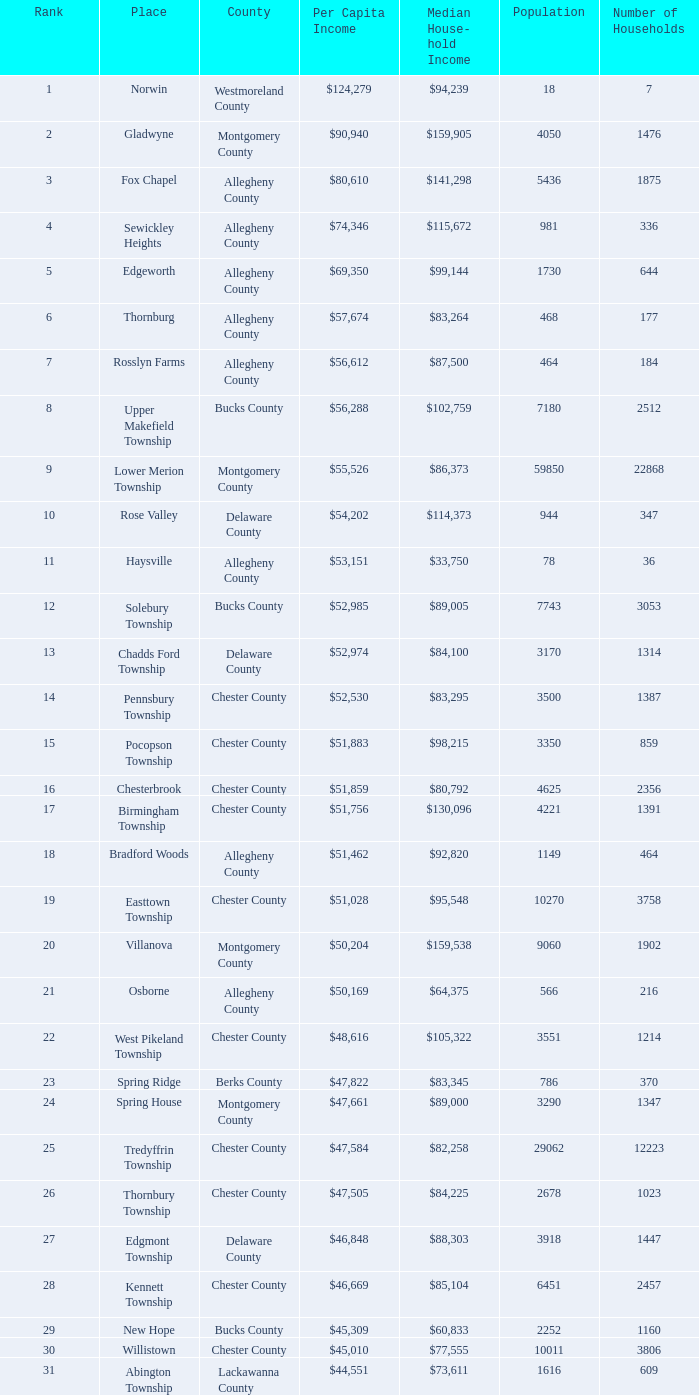Which county has a median household income of  $98,090? Bucks County. 